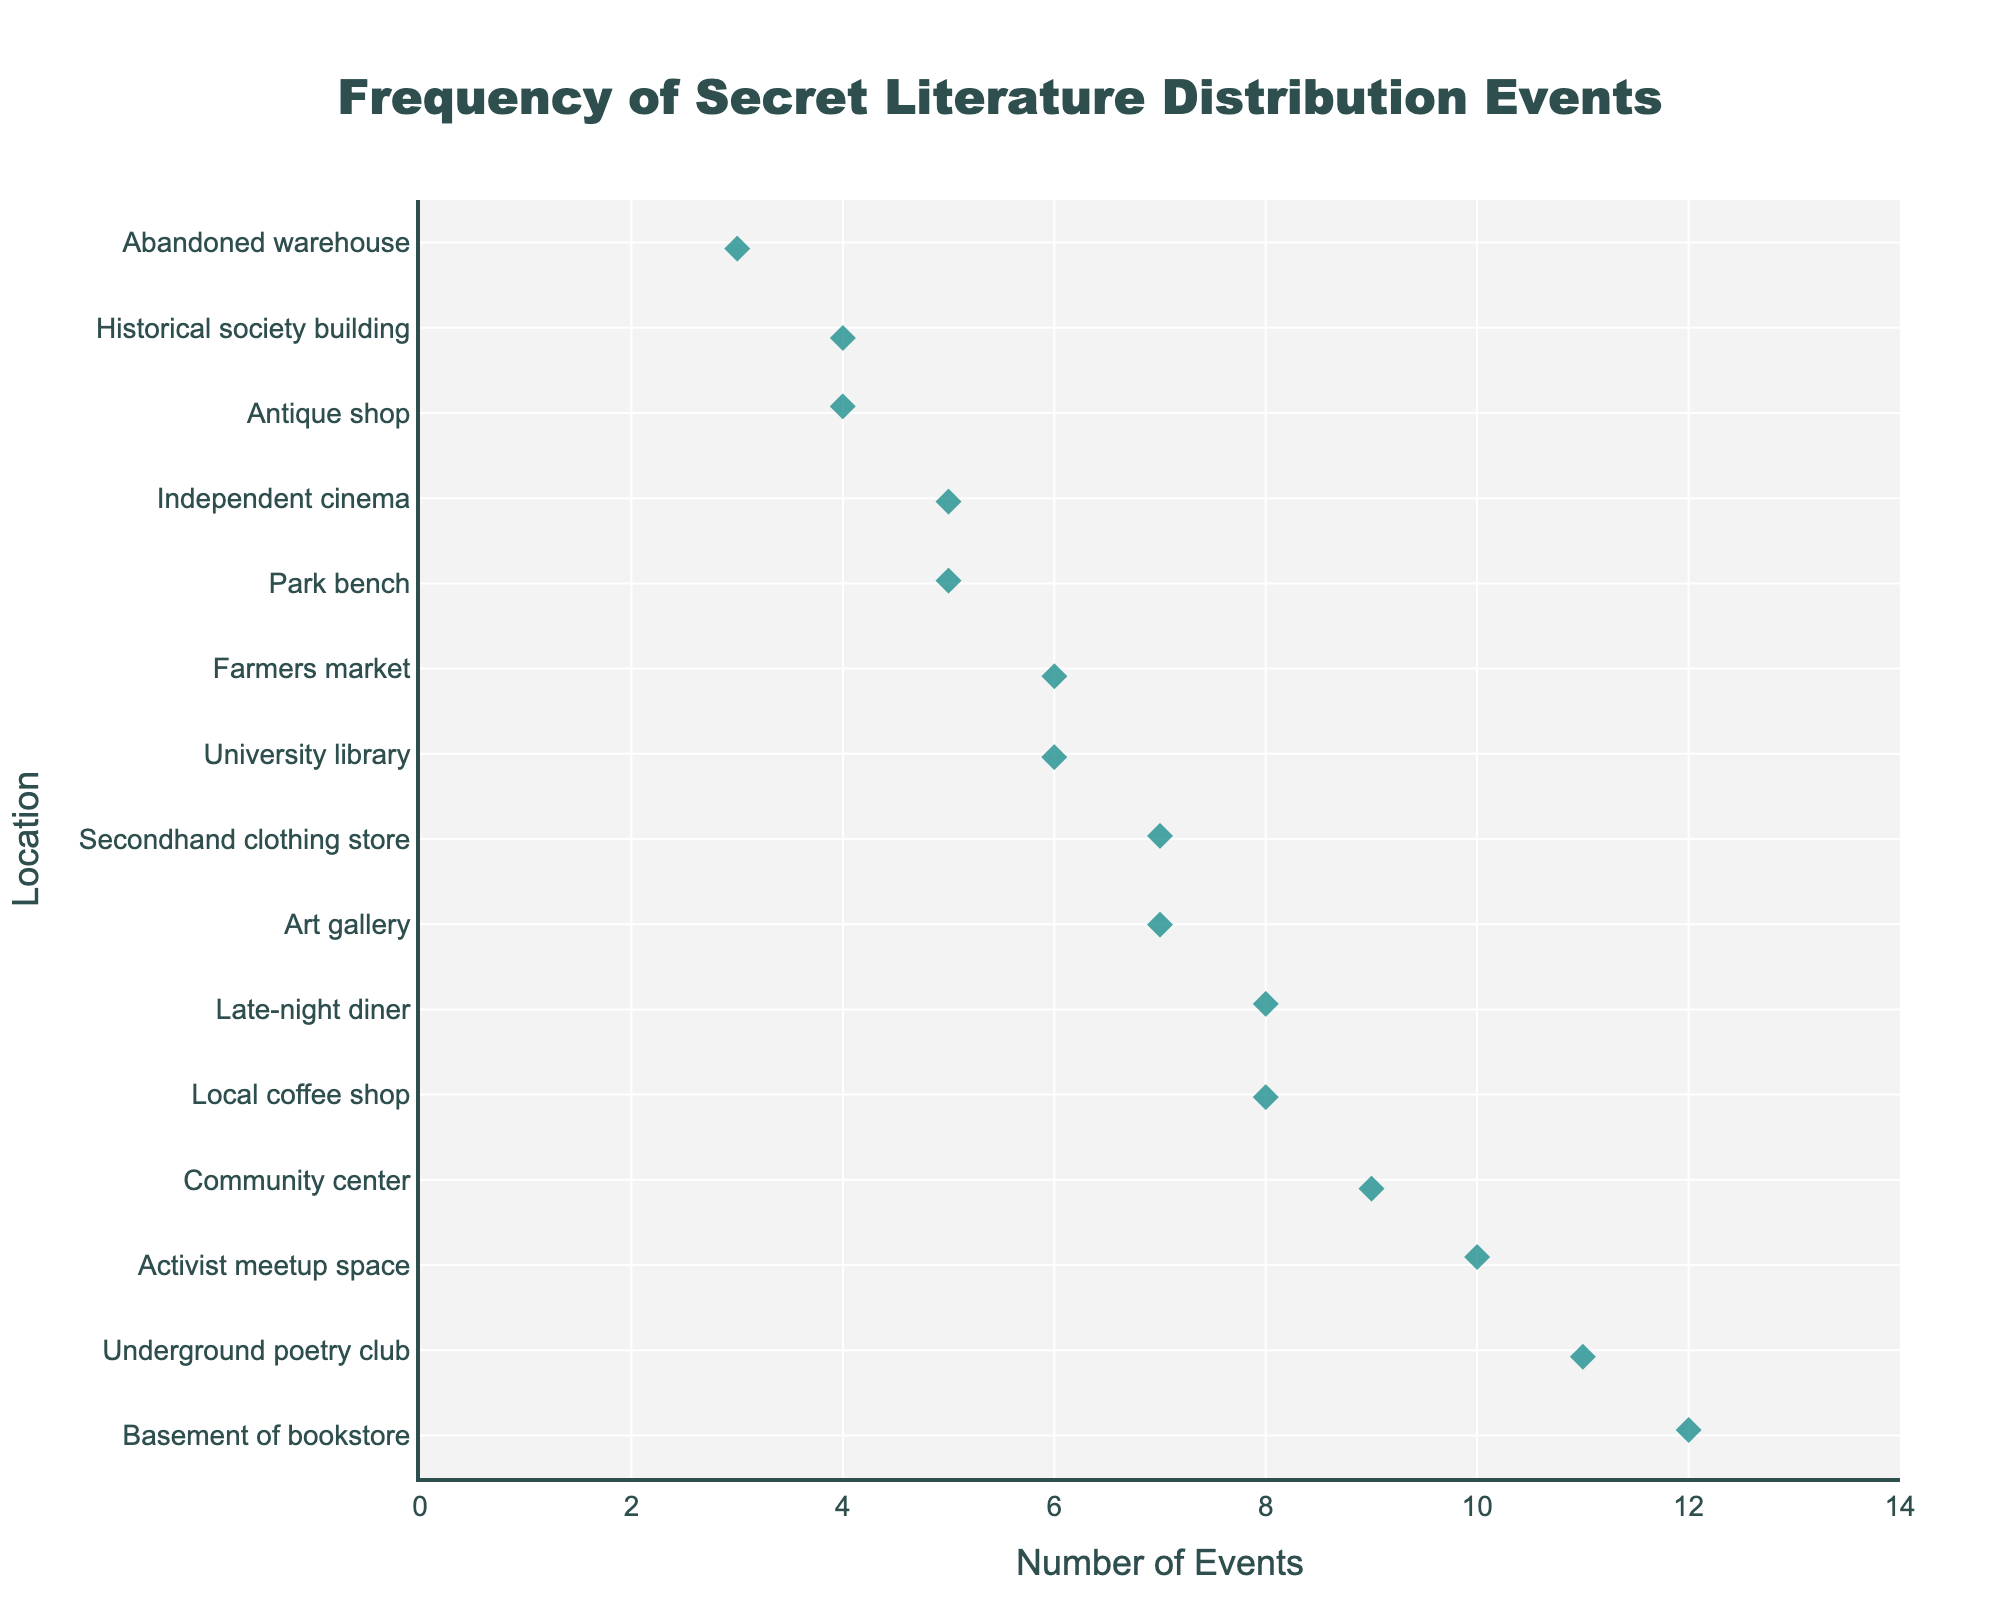What is the title of the figure? The title is positioned at the top of the figure and provides a summary of what the plot is about. In this case, it should be clearly displayed and can be read directly from the image.
Answer: Frequency of Secret Literature Distribution Events What location has the highest frequency of distribution events? Look for the location with the highest value on the x-axis, which represents the number of events. The corresponding y-axis label will be the location with the highest frequency.
Answer: Basement of bookstore How many locations have a frequency of 5 distribution events? Count the number of data points that align with the value 5 on the x-axis. Identify the corresponding locations by checking their y-axis labels.
Answer: Two Which locations have more than 10 distribution events? Find data points with x-axis values greater than 10. The corresponding y-axis labels will indicate the locations.
Answer: Basement of bookstore, Underground poetry club What's the combined number of distribution events for Local coffee shop and Late-night diner? Identify the x-axis values for both locations, then sum them up. Local coffee shop has 8 events, and Late-night diner has 8 events. So, 8 + 8 = 16.
Answer: 16 Which location has the least number of distribution events, and what is their count? Look for the data point with the smallest x-axis value and check the corresponding y-axis label for the location.
Answer: Abandoned warehouse, 3 How many locations have between 6 and 9 distribution events? Count the number of data points that fall within the range of 6 to 9 on the x-axis, inclusive. Then list these locations.
Answer: Six Compare the number of events at Community center versus Art gallery. Which location has more, and by how many? Identify the x-axis values for both locations and subtract the smaller value from the larger one. Community center has 9 events, and Art gallery has 7 events. So, 9 - 7 = 2, and Community center has more.
Answer: Community center has more by 2 What is the average number of distribution events across all locations? Sum the number of events for all locations, then divide by the total number of locations. The values are 12, 8, 6, 9, 5, 3, 11, 7, 4, 6, 5, 8, 10, 4, and 7. Total is 105. Number of locations is 15. So, 105 / 15 = 7.
Answer: 7 What is the interquartile range (IQR) for the distribution events? Sort the values and find Q1 (first quartile) and Q3 (third quartile). Then subtract Q1 from Q3. The sorted values are 3, 4, 4, 5, 5, 6, 6, 7, 7, 8, 8, 9, 10, 11, 12. Q1 is the median of the first half (4.5) and Q3 is the median of the second half (8.5). So, IQR = 8.5 - 4.5 = 4.
Answer: 4 